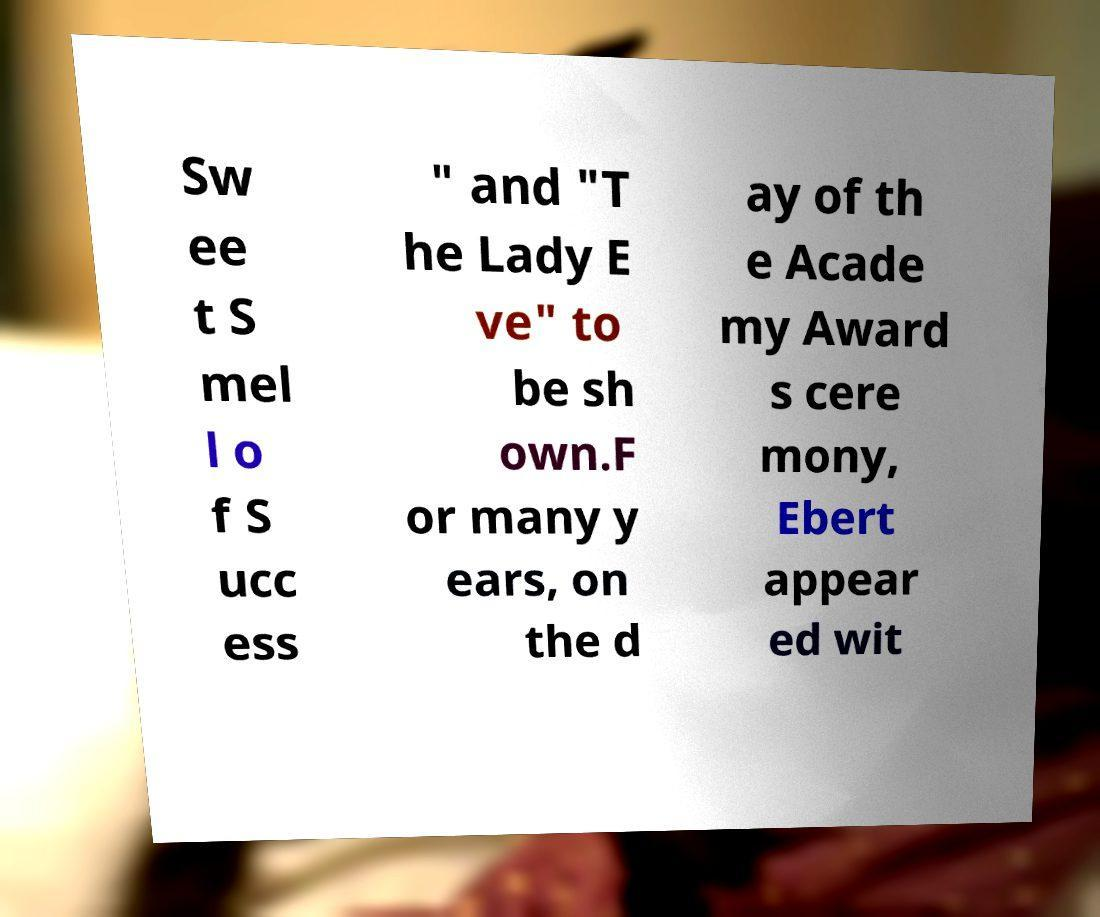Can you accurately transcribe the text from the provided image for me? Sw ee t S mel l o f S ucc ess " and "T he Lady E ve" to be sh own.F or many y ears, on the d ay of th e Acade my Award s cere mony, Ebert appear ed wit 